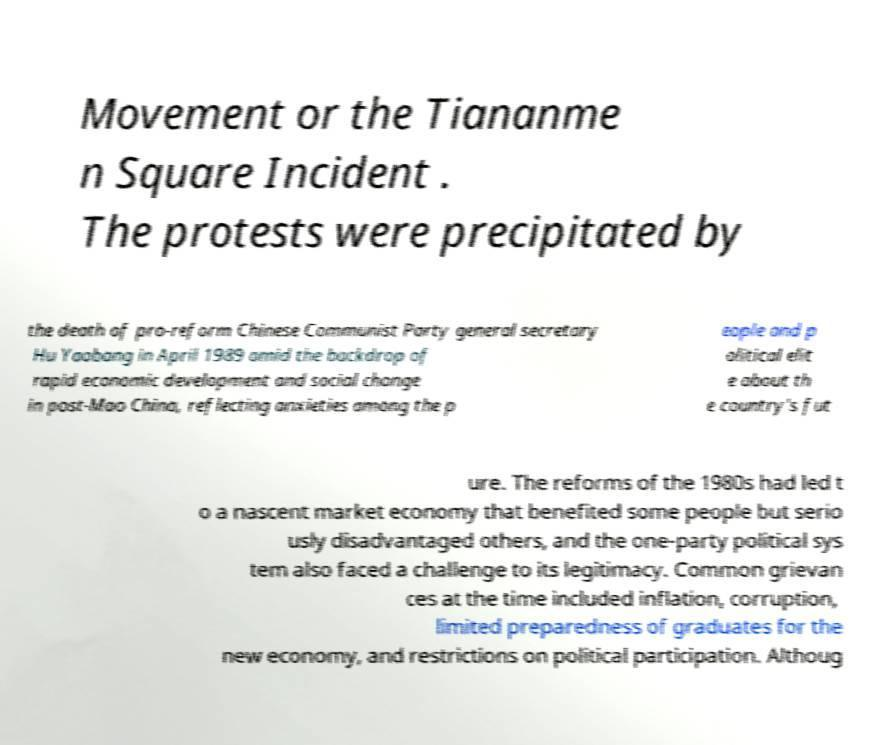Can you accurately transcribe the text from the provided image for me? Movement or the Tiananme n Square Incident . The protests were precipitated by the death of pro-reform Chinese Communist Party general secretary Hu Yaobang in April 1989 amid the backdrop of rapid economic development and social change in post-Mao China, reflecting anxieties among the p eople and p olitical elit e about th e country's fut ure. The reforms of the 1980s had led t o a nascent market economy that benefited some people but serio usly disadvantaged others, and the one-party political sys tem also faced a challenge to its legitimacy. Common grievan ces at the time included inflation, corruption, limited preparedness of graduates for the new economy, and restrictions on political participation. Althoug 